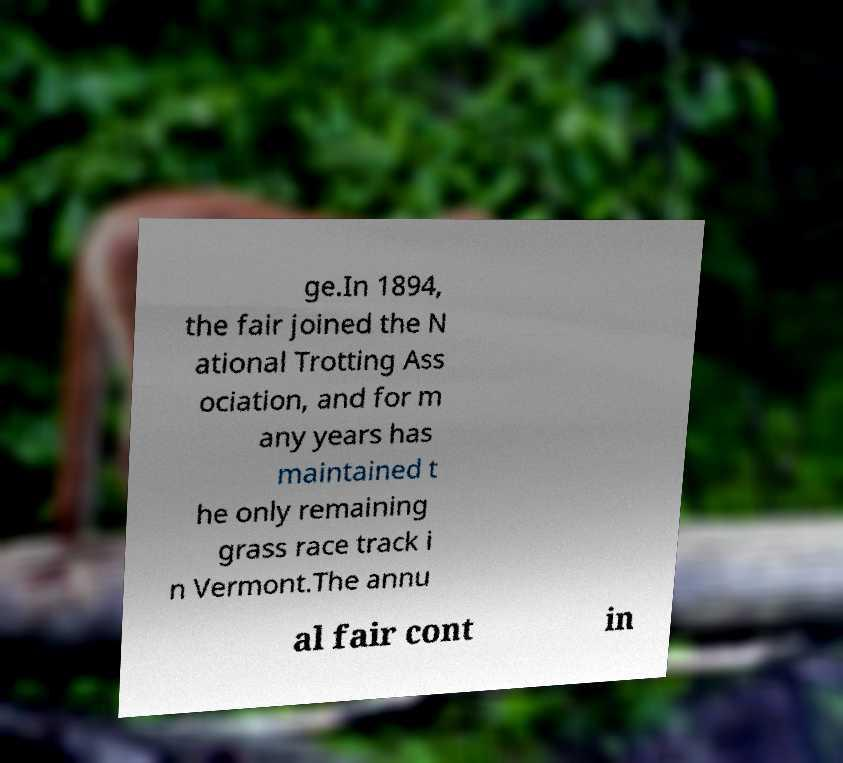I need the written content from this picture converted into text. Can you do that? ge.In 1894, the fair joined the N ational Trotting Ass ociation, and for m any years has maintained t he only remaining grass race track i n Vermont.The annu al fair cont in 